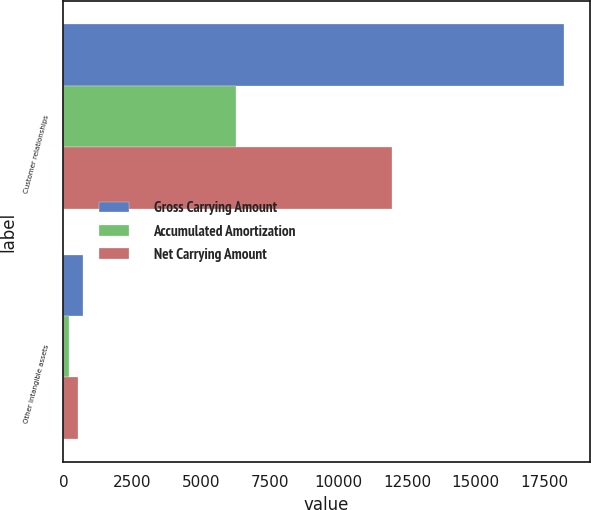Convert chart. <chart><loc_0><loc_0><loc_500><loc_500><stacked_bar_chart><ecel><fcel>Customer relationships<fcel>Other intangible assets<nl><fcel>Gross Carrying Amount<fcel>18229<fcel>731<nl><fcel>Accumulated Amortization<fcel>6278<fcel>201<nl><fcel>Net Carrying Amount<fcel>11951<fcel>530<nl></chart> 